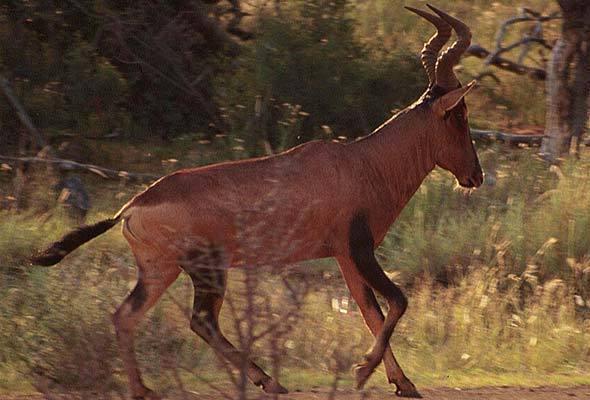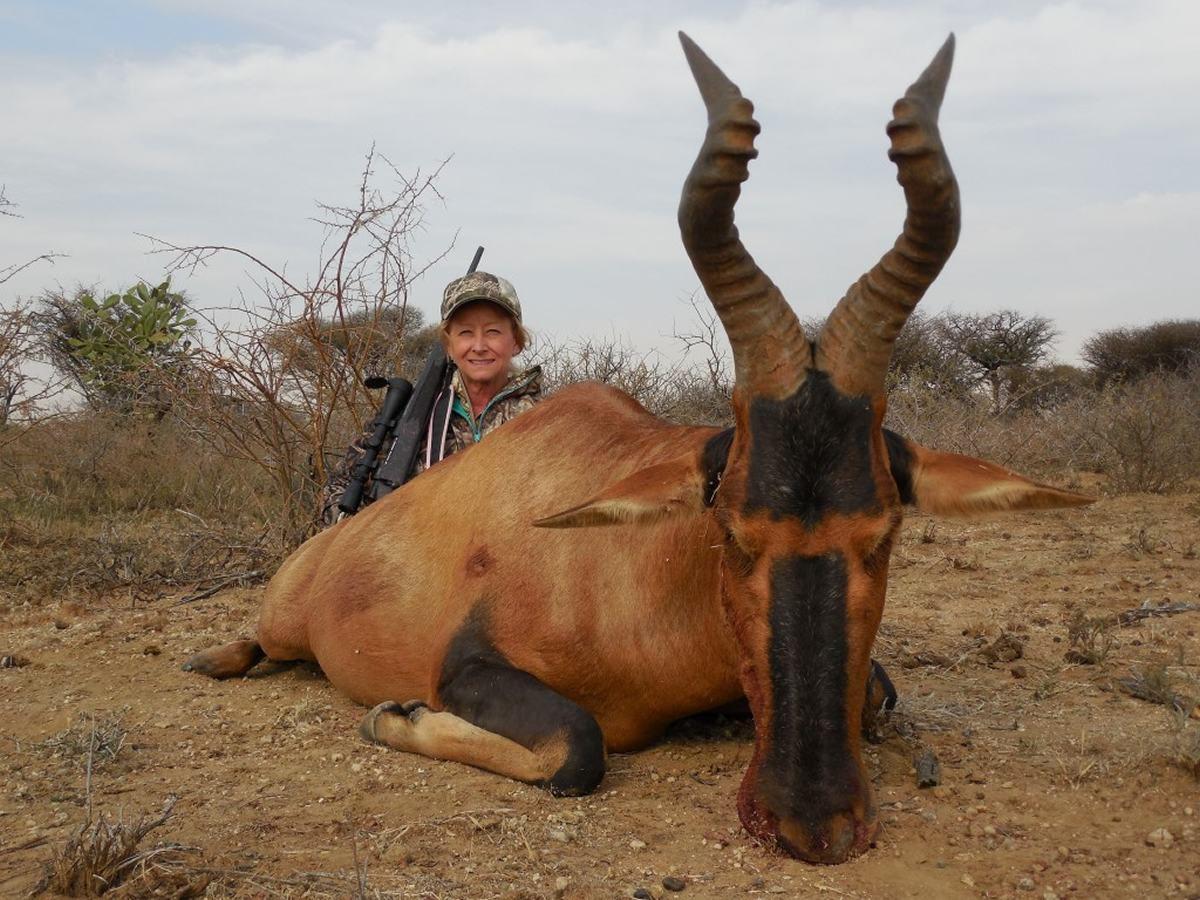The first image is the image on the left, the second image is the image on the right. Analyze the images presented: Is the assertion "The animal in the image on the right is lying down." valid? Answer yes or no. Yes. 